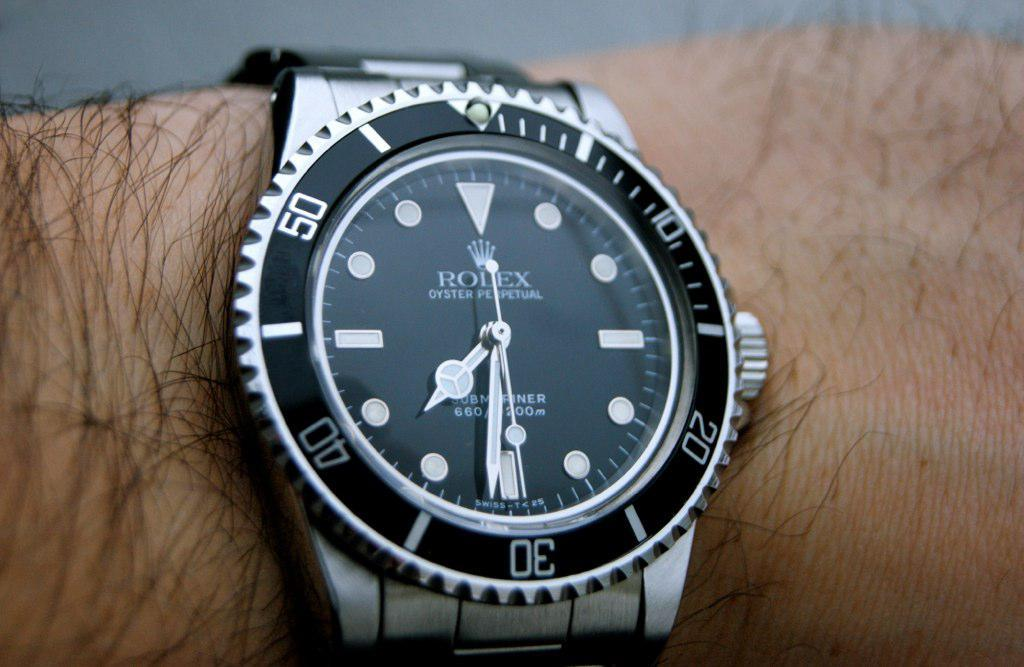Provide a one-sentence caption for the provided image. A silver Rolex branded watch has the time of 7:31. 